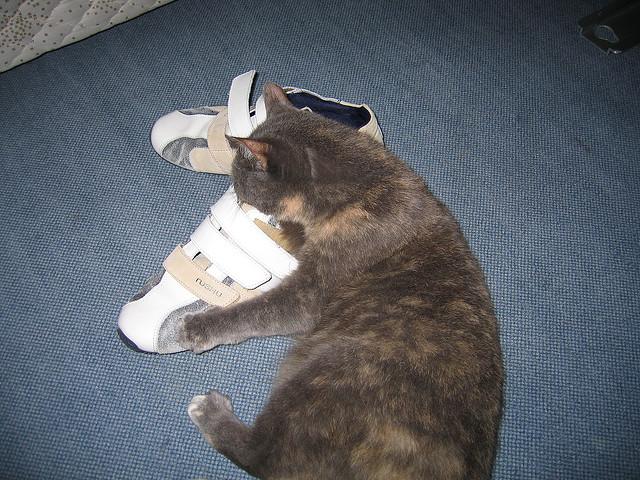What type of animal is this?
Concise answer only. Cat. Where is the animals head?
Concise answer only. In shoe. Is the cat sleeping?
Quick response, please. No. 